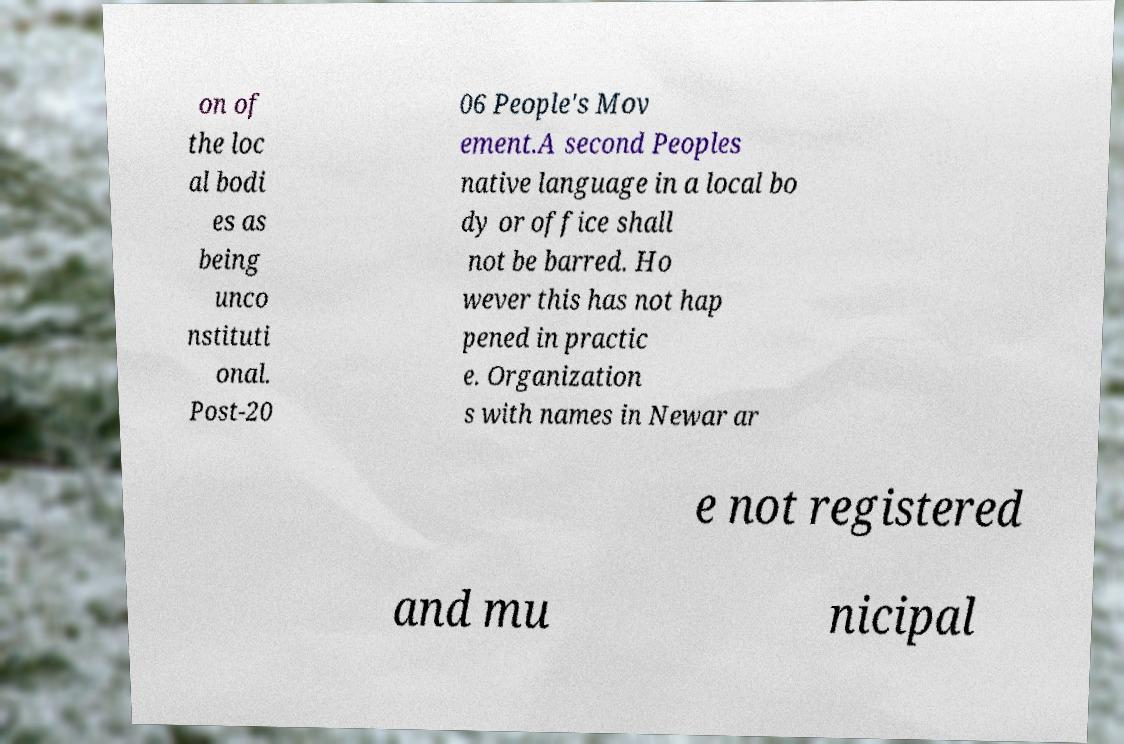Please read and relay the text visible in this image. What does it say? on of the loc al bodi es as being unco nstituti onal. Post-20 06 People's Mov ement.A second Peoples native language in a local bo dy or office shall not be barred. Ho wever this has not hap pened in practic e. Organization s with names in Newar ar e not registered and mu nicipal 